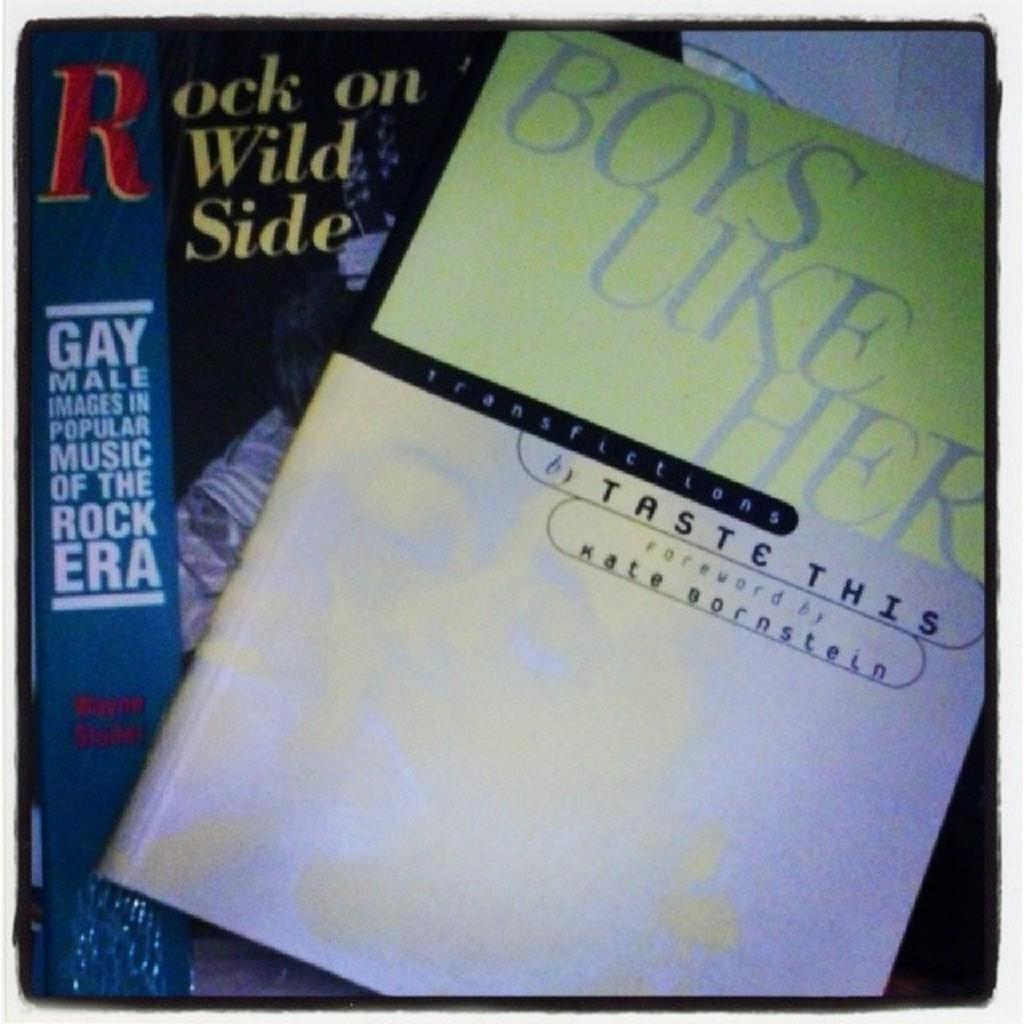<image>
Render a clear and concise summary of the photo. Rock on the Wild Side is a book about gay musicians. 